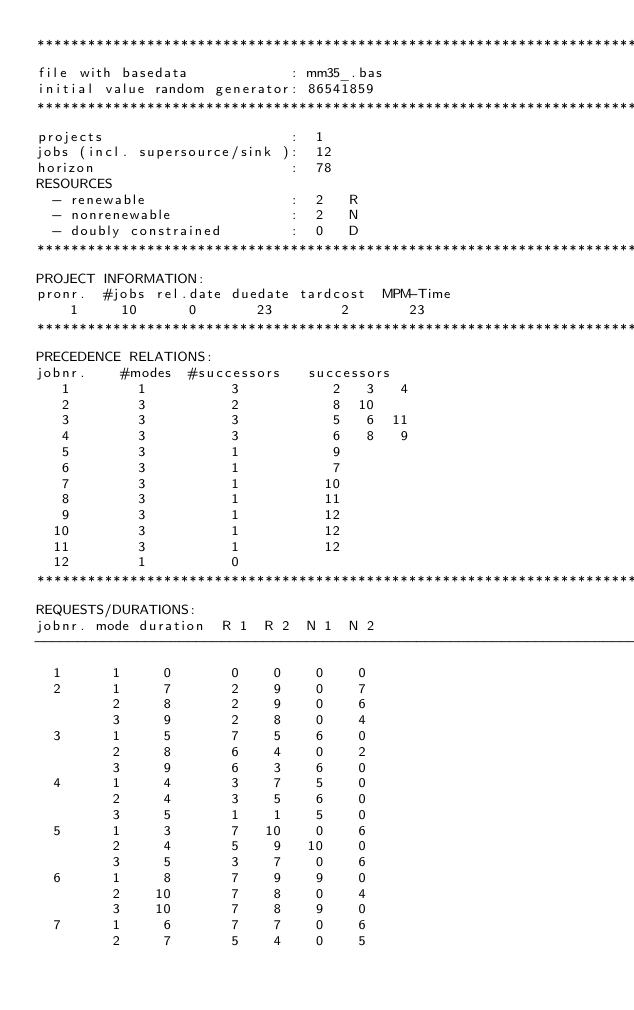Convert code to text. <code><loc_0><loc_0><loc_500><loc_500><_ObjectiveC_>************************************************************************
file with basedata            : mm35_.bas
initial value random generator: 86541859
************************************************************************
projects                      :  1
jobs (incl. supersource/sink ):  12
horizon                       :  78
RESOURCES
  - renewable                 :  2   R
  - nonrenewable              :  2   N
  - doubly constrained        :  0   D
************************************************************************
PROJECT INFORMATION:
pronr.  #jobs rel.date duedate tardcost  MPM-Time
    1     10      0       23        2       23
************************************************************************
PRECEDENCE RELATIONS:
jobnr.    #modes  #successors   successors
   1        1          3           2   3   4
   2        3          2           8  10
   3        3          3           5   6  11
   4        3          3           6   8   9
   5        3          1           9
   6        3          1           7
   7        3          1          10
   8        3          1          11
   9        3          1          12
  10        3          1          12
  11        3          1          12
  12        1          0        
************************************************************************
REQUESTS/DURATIONS:
jobnr. mode duration  R 1  R 2  N 1  N 2
------------------------------------------------------------------------
  1      1     0       0    0    0    0
  2      1     7       2    9    0    7
         2     8       2    9    0    6
         3     9       2    8    0    4
  3      1     5       7    5    6    0
         2     8       6    4    0    2
         3     9       6    3    6    0
  4      1     4       3    7    5    0
         2     4       3    5    6    0
         3     5       1    1    5    0
  5      1     3       7   10    0    6
         2     4       5    9   10    0
         3     5       3    7    0    6
  6      1     8       7    9    9    0
         2    10       7    8    0    4
         3    10       7    8    9    0
  7      1     6       7    7    0    6
         2     7       5    4    0    5</code> 